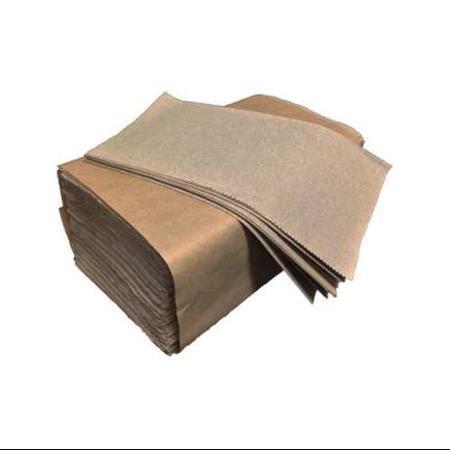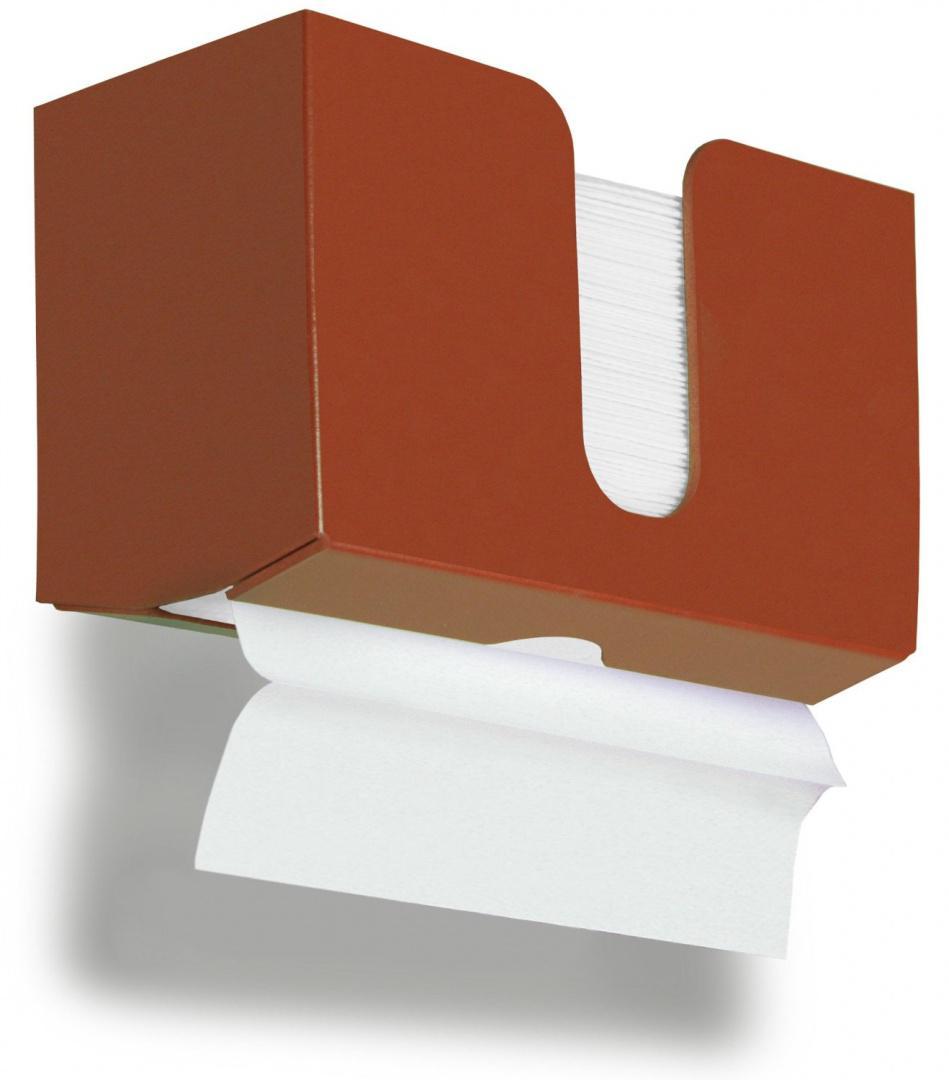The first image is the image on the left, the second image is the image on the right. For the images shown, is this caption "the right pic has a stack of tissues without holder" true? Answer yes or no. No. The first image is the image on the left, the second image is the image on the right. Examine the images to the left and right. Is the description "The image to the right features brown squares of paper towels." accurate? Answer yes or no. No. 